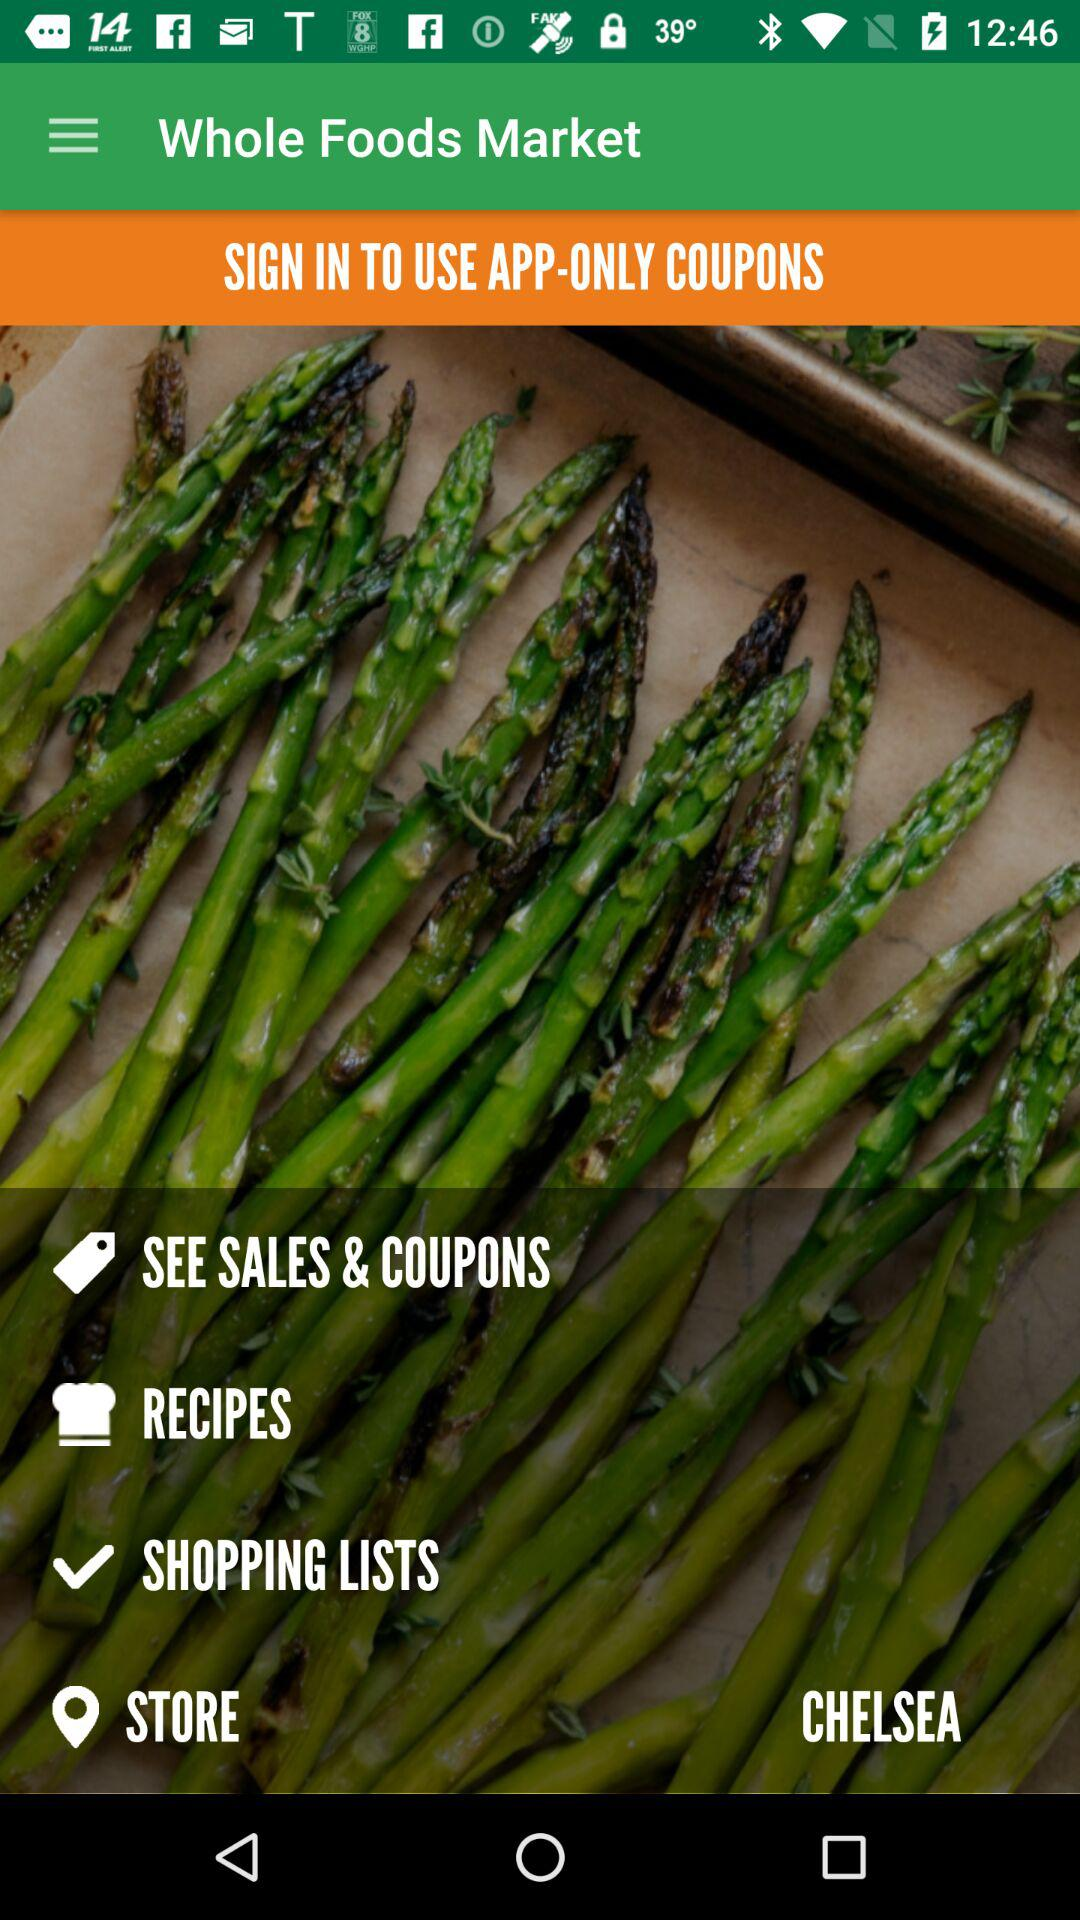What are the different available sections? The different available sections are "SEE SALES & COUPONS", "RECIPES", "SHOPPING LISTS" and "STORE". 